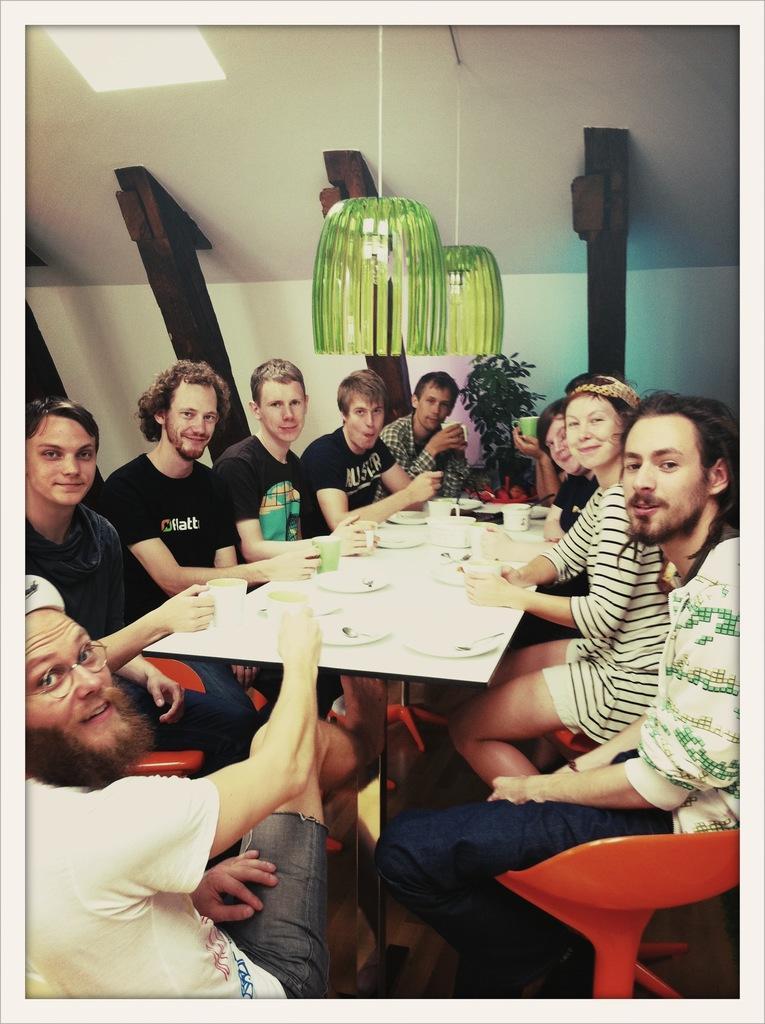Can you describe this image briefly? In this image I can see few people are sitting on chairs, I can also see smile on few faces. On this table I can see few plates and mugs. In the background I can see a plant. 